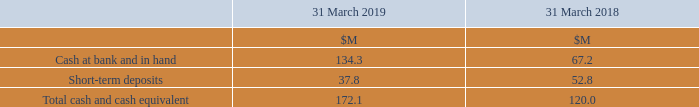21 Cash and Cash Equivalents
Cash at bank earns interest at floating rates based on daily bank deposit rates. Short-term deposits are made for varying periods of between one day and three months, depending on the immediate cash requirements of the Group, and earn interest at the respective short-term deposit rates.
How does cash at bank earn interest? At floating rates based on daily bank deposit rates. What are short-term deposits made for? For varying periods of between one day and three months, depending on the immediate cash requirements of the group, and earn interest at the respective short-term deposit rates. What are the components making up the total cash and cash equivalents? Cash at bank and in hand, short-term deposits. In which year was the amount of short-term deposits larger? 37.8>52.8
Answer: 2018. What was the change in the Total cash and cash equivalent in 2019 from 2018?
Answer scale should be: million. 172.1-120.0
Answer: 52.1. What was the percentage change in the Total cash and cash equivalent in 2019 from 2018?
Answer scale should be: percent. (172.1-120.0)/120.0
Answer: 43.42. 